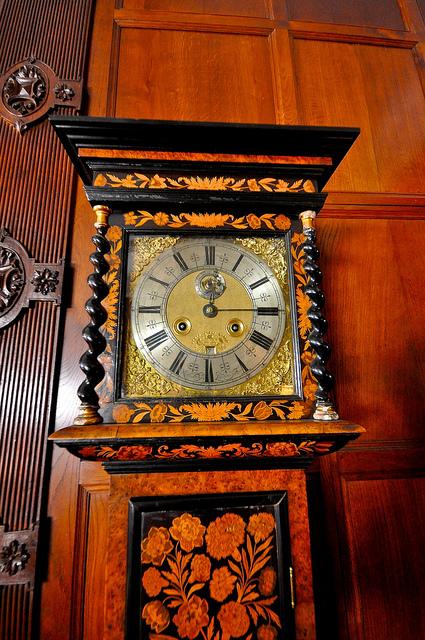Is this a grandfather clock?
Give a very brief answer. Yes. What is the clock up against?
Keep it brief. Wall. What time does the clock read?
Answer briefly. 12:15. 